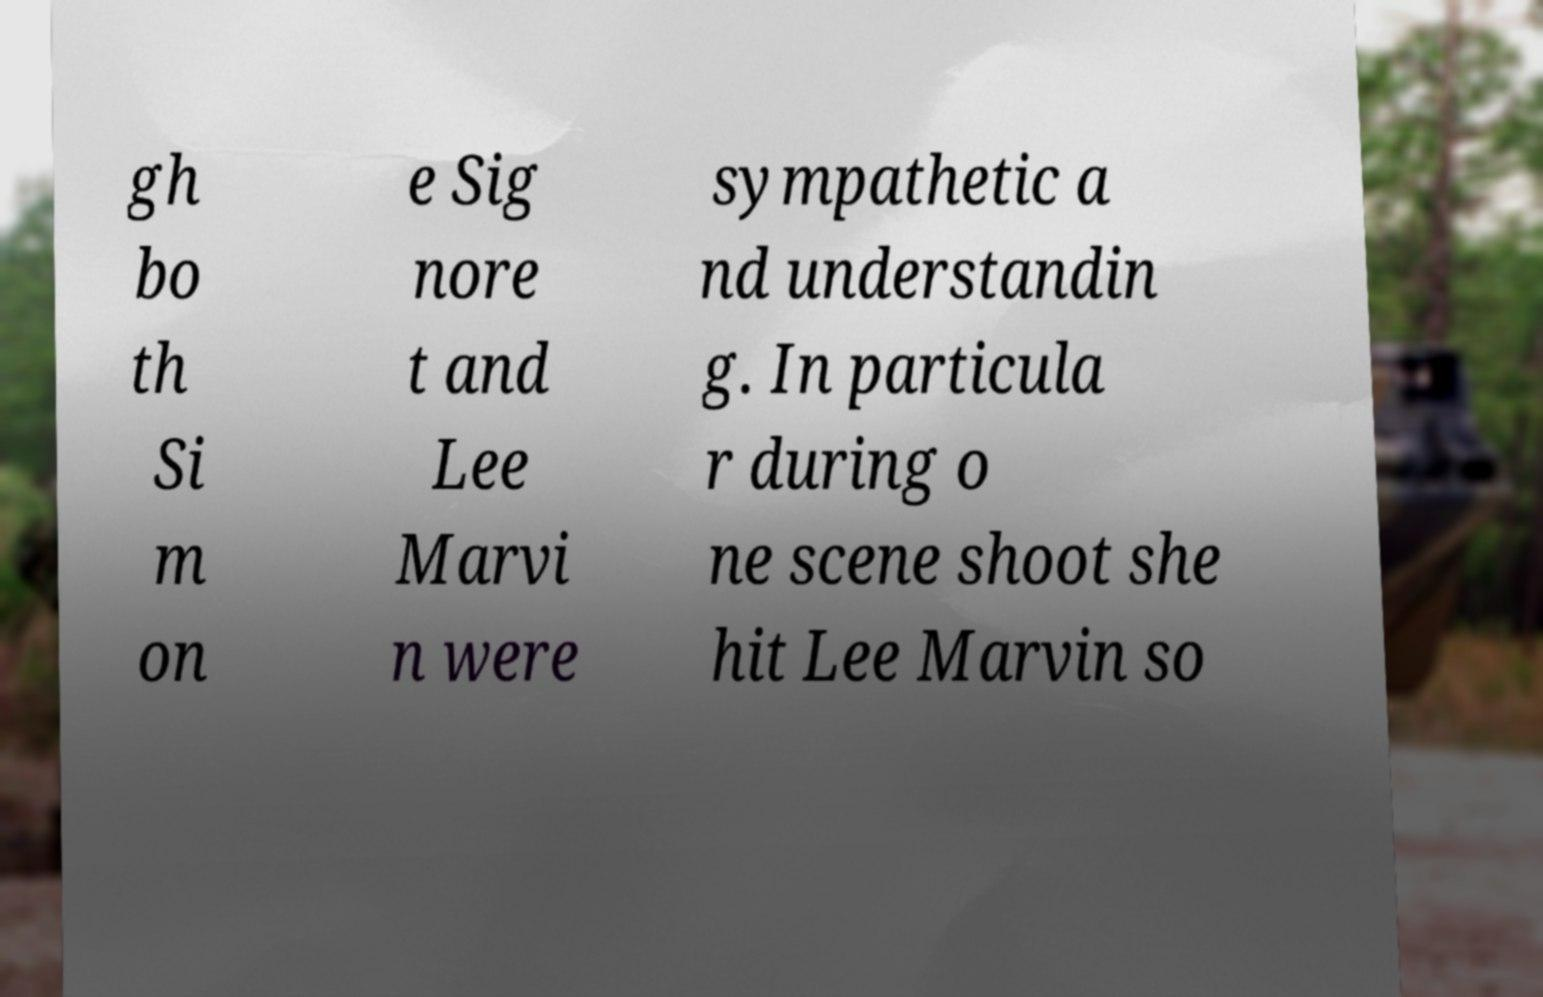Can you read and provide the text displayed in the image?This photo seems to have some interesting text. Can you extract and type it out for me? gh bo th Si m on e Sig nore t and Lee Marvi n were sympathetic a nd understandin g. In particula r during o ne scene shoot she hit Lee Marvin so 